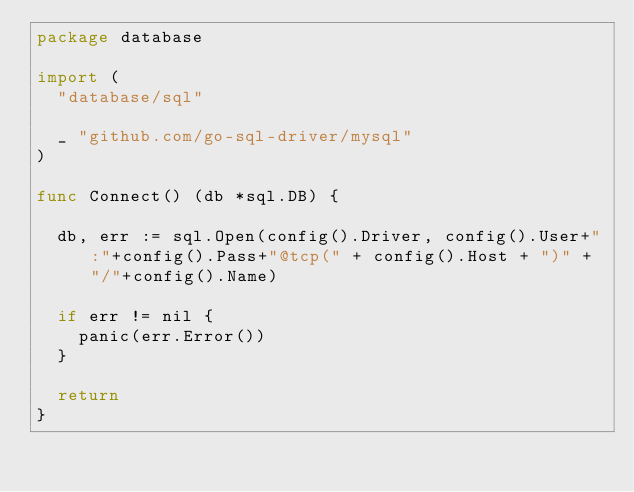<code> <loc_0><loc_0><loc_500><loc_500><_Go_>package database

import (
	"database/sql"

	_ "github.com/go-sql-driver/mysql"
)

func Connect() (db *sql.DB) {

	db, err := sql.Open(config().Driver, config().User+":"+config().Pass+"@tcp(" + config().Host + ")" + "/"+config().Name)

	if err != nil {
		panic(err.Error())
	}

	return
}
</code> 